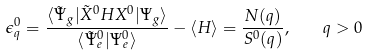Convert formula to latex. <formula><loc_0><loc_0><loc_500><loc_500>\epsilon ^ { 0 } _ { q } = \frac { \langle \tilde { \Psi } _ { g } | \tilde { X } ^ { 0 } H X ^ { 0 } | \Psi _ { g } \rangle } { \langle \tilde { \Psi } _ { e } ^ { 0 } | \Psi _ { e } ^ { 0 } \rangle } - \langle H \rangle = \frac { N ( q ) } { S ^ { 0 } ( q ) } , \quad q > 0</formula> 